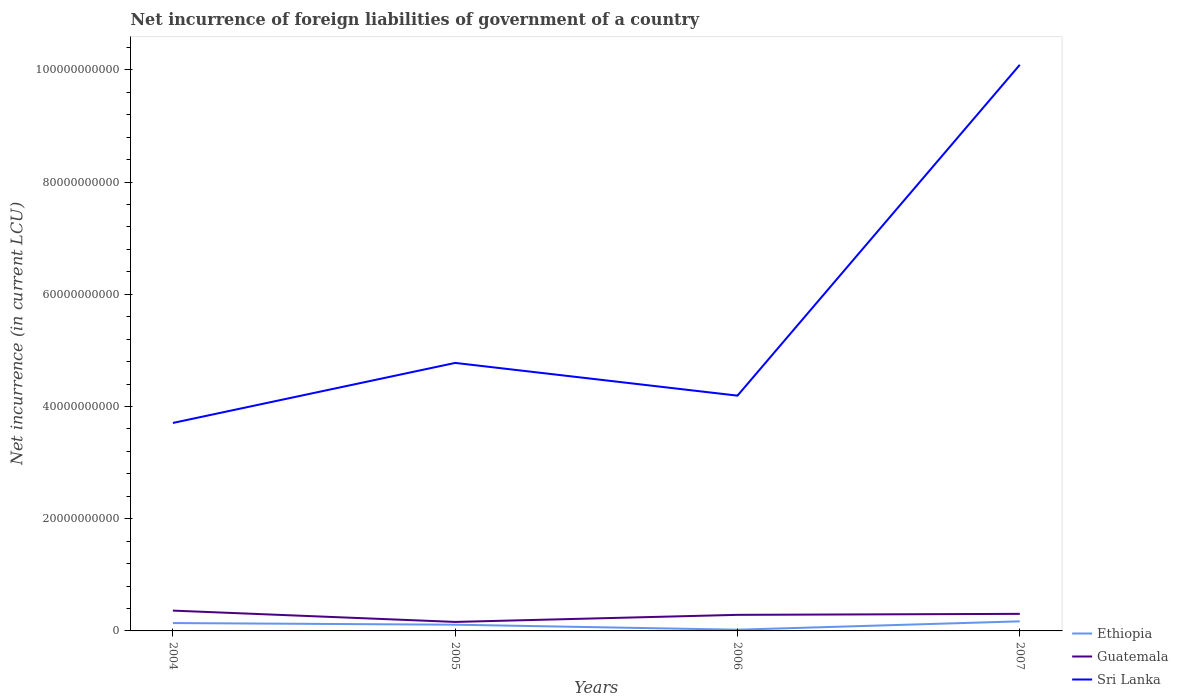Is the number of lines equal to the number of legend labels?
Offer a very short reply. Yes. Across all years, what is the maximum net incurrence of foreign liabilities in Sri Lanka?
Provide a succinct answer. 3.71e+1. What is the total net incurrence of foreign liabilities in Guatemala in the graph?
Your answer should be compact. -1.44e+09. What is the difference between the highest and the second highest net incurrence of foreign liabilities in Guatemala?
Provide a short and direct response. 2.02e+09. What is the difference between the highest and the lowest net incurrence of foreign liabilities in Sri Lanka?
Keep it short and to the point. 1. Are the values on the major ticks of Y-axis written in scientific E-notation?
Offer a very short reply. No. Does the graph contain any zero values?
Keep it short and to the point. No. How are the legend labels stacked?
Your answer should be compact. Vertical. What is the title of the graph?
Your response must be concise. Net incurrence of foreign liabilities of government of a country. What is the label or title of the X-axis?
Your response must be concise. Years. What is the label or title of the Y-axis?
Ensure brevity in your answer.  Net incurrence (in current LCU). What is the Net incurrence (in current LCU) in Ethiopia in 2004?
Make the answer very short. 1.40e+09. What is the Net incurrence (in current LCU) of Guatemala in 2004?
Make the answer very short. 3.62e+09. What is the Net incurrence (in current LCU) of Sri Lanka in 2004?
Make the answer very short. 3.71e+1. What is the Net incurrence (in current LCU) of Ethiopia in 2005?
Give a very brief answer. 1.11e+09. What is the Net incurrence (in current LCU) in Guatemala in 2005?
Ensure brevity in your answer.  1.60e+09. What is the Net incurrence (in current LCU) in Sri Lanka in 2005?
Keep it short and to the point. 4.78e+1. What is the Net incurrence (in current LCU) in Ethiopia in 2006?
Offer a terse response. 2.18e+08. What is the Net incurrence (in current LCU) of Guatemala in 2006?
Make the answer very short. 2.87e+09. What is the Net incurrence (in current LCU) of Sri Lanka in 2006?
Provide a succinct answer. 4.19e+1. What is the Net incurrence (in current LCU) of Ethiopia in 2007?
Offer a terse response. 1.71e+09. What is the Net incurrence (in current LCU) of Guatemala in 2007?
Your answer should be very brief. 3.04e+09. What is the Net incurrence (in current LCU) of Sri Lanka in 2007?
Keep it short and to the point. 1.01e+11. Across all years, what is the maximum Net incurrence (in current LCU) of Ethiopia?
Your answer should be very brief. 1.71e+09. Across all years, what is the maximum Net incurrence (in current LCU) of Guatemala?
Keep it short and to the point. 3.62e+09. Across all years, what is the maximum Net incurrence (in current LCU) in Sri Lanka?
Provide a succinct answer. 1.01e+11. Across all years, what is the minimum Net incurrence (in current LCU) in Ethiopia?
Your response must be concise. 2.18e+08. Across all years, what is the minimum Net incurrence (in current LCU) of Guatemala?
Offer a terse response. 1.60e+09. Across all years, what is the minimum Net incurrence (in current LCU) in Sri Lanka?
Give a very brief answer. 3.71e+1. What is the total Net incurrence (in current LCU) in Ethiopia in the graph?
Offer a terse response. 4.44e+09. What is the total Net incurrence (in current LCU) of Guatemala in the graph?
Provide a succinct answer. 1.11e+1. What is the total Net incurrence (in current LCU) in Sri Lanka in the graph?
Make the answer very short. 2.28e+11. What is the difference between the Net incurrence (in current LCU) of Ethiopia in 2004 and that in 2005?
Make the answer very short. 2.96e+08. What is the difference between the Net incurrence (in current LCU) of Guatemala in 2004 and that in 2005?
Provide a short and direct response. 2.02e+09. What is the difference between the Net incurrence (in current LCU) in Sri Lanka in 2004 and that in 2005?
Give a very brief answer. -1.07e+1. What is the difference between the Net incurrence (in current LCU) in Ethiopia in 2004 and that in 2006?
Make the answer very short. 1.18e+09. What is the difference between the Net incurrence (in current LCU) in Guatemala in 2004 and that in 2006?
Your response must be concise. 7.54e+08. What is the difference between the Net incurrence (in current LCU) in Sri Lanka in 2004 and that in 2006?
Provide a short and direct response. -4.87e+09. What is the difference between the Net incurrence (in current LCU) in Ethiopia in 2004 and that in 2007?
Your response must be concise. -3.04e+08. What is the difference between the Net incurrence (in current LCU) of Guatemala in 2004 and that in 2007?
Give a very brief answer. 5.80e+08. What is the difference between the Net incurrence (in current LCU) in Sri Lanka in 2004 and that in 2007?
Ensure brevity in your answer.  -6.38e+1. What is the difference between the Net incurrence (in current LCU) in Ethiopia in 2005 and that in 2006?
Your answer should be compact. 8.89e+08. What is the difference between the Net incurrence (in current LCU) in Guatemala in 2005 and that in 2006?
Keep it short and to the point. -1.26e+09. What is the difference between the Net incurrence (in current LCU) in Sri Lanka in 2005 and that in 2006?
Ensure brevity in your answer.  5.83e+09. What is the difference between the Net incurrence (in current LCU) in Ethiopia in 2005 and that in 2007?
Offer a very short reply. -6.00e+08. What is the difference between the Net incurrence (in current LCU) of Guatemala in 2005 and that in 2007?
Your answer should be very brief. -1.44e+09. What is the difference between the Net incurrence (in current LCU) in Sri Lanka in 2005 and that in 2007?
Your response must be concise. -5.31e+1. What is the difference between the Net incurrence (in current LCU) of Ethiopia in 2006 and that in 2007?
Your response must be concise. -1.49e+09. What is the difference between the Net incurrence (in current LCU) of Guatemala in 2006 and that in 2007?
Ensure brevity in your answer.  -1.74e+08. What is the difference between the Net incurrence (in current LCU) in Sri Lanka in 2006 and that in 2007?
Offer a very short reply. -5.90e+1. What is the difference between the Net incurrence (in current LCU) in Ethiopia in 2004 and the Net incurrence (in current LCU) in Guatemala in 2005?
Provide a short and direct response. -2.00e+08. What is the difference between the Net incurrence (in current LCU) in Ethiopia in 2004 and the Net incurrence (in current LCU) in Sri Lanka in 2005?
Make the answer very short. -4.64e+1. What is the difference between the Net incurrence (in current LCU) of Guatemala in 2004 and the Net incurrence (in current LCU) of Sri Lanka in 2005?
Offer a very short reply. -4.42e+1. What is the difference between the Net incurrence (in current LCU) of Ethiopia in 2004 and the Net incurrence (in current LCU) of Guatemala in 2006?
Keep it short and to the point. -1.46e+09. What is the difference between the Net incurrence (in current LCU) in Ethiopia in 2004 and the Net incurrence (in current LCU) in Sri Lanka in 2006?
Your answer should be very brief. -4.05e+1. What is the difference between the Net incurrence (in current LCU) in Guatemala in 2004 and the Net incurrence (in current LCU) in Sri Lanka in 2006?
Ensure brevity in your answer.  -3.83e+1. What is the difference between the Net incurrence (in current LCU) in Ethiopia in 2004 and the Net incurrence (in current LCU) in Guatemala in 2007?
Provide a short and direct response. -1.64e+09. What is the difference between the Net incurrence (in current LCU) of Ethiopia in 2004 and the Net incurrence (in current LCU) of Sri Lanka in 2007?
Ensure brevity in your answer.  -9.95e+1. What is the difference between the Net incurrence (in current LCU) of Guatemala in 2004 and the Net incurrence (in current LCU) of Sri Lanka in 2007?
Offer a very short reply. -9.73e+1. What is the difference between the Net incurrence (in current LCU) in Ethiopia in 2005 and the Net incurrence (in current LCU) in Guatemala in 2006?
Keep it short and to the point. -1.76e+09. What is the difference between the Net incurrence (in current LCU) of Ethiopia in 2005 and the Net incurrence (in current LCU) of Sri Lanka in 2006?
Your answer should be compact. -4.08e+1. What is the difference between the Net incurrence (in current LCU) of Guatemala in 2005 and the Net incurrence (in current LCU) of Sri Lanka in 2006?
Make the answer very short. -4.03e+1. What is the difference between the Net incurrence (in current LCU) of Ethiopia in 2005 and the Net incurrence (in current LCU) of Guatemala in 2007?
Keep it short and to the point. -1.93e+09. What is the difference between the Net incurrence (in current LCU) of Ethiopia in 2005 and the Net incurrence (in current LCU) of Sri Lanka in 2007?
Make the answer very short. -9.98e+1. What is the difference between the Net incurrence (in current LCU) in Guatemala in 2005 and the Net incurrence (in current LCU) in Sri Lanka in 2007?
Your answer should be very brief. -9.93e+1. What is the difference between the Net incurrence (in current LCU) of Ethiopia in 2006 and the Net incurrence (in current LCU) of Guatemala in 2007?
Ensure brevity in your answer.  -2.82e+09. What is the difference between the Net incurrence (in current LCU) of Ethiopia in 2006 and the Net incurrence (in current LCU) of Sri Lanka in 2007?
Offer a terse response. -1.01e+11. What is the difference between the Net incurrence (in current LCU) of Guatemala in 2006 and the Net incurrence (in current LCU) of Sri Lanka in 2007?
Provide a succinct answer. -9.80e+1. What is the average Net incurrence (in current LCU) of Ethiopia per year?
Ensure brevity in your answer.  1.11e+09. What is the average Net incurrence (in current LCU) in Guatemala per year?
Your answer should be compact. 2.78e+09. What is the average Net incurrence (in current LCU) of Sri Lanka per year?
Provide a short and direct response. 5.69e+1. In the year 2004, what is the difference between the Net incurrence (in current LCU) of Ethiopia and Net incurrence (in current LCU) of Guatemala?
Offer a very short reply. -2.22e+09. In the year 2004, what is the difference between the Net incurrence (in current LCU) of Ethiopia and Net incurrence (in current LCU) of Sri Lanka?
Your answer should be compact. -3.57e+1. In the year 2004, what is the difference between the Net incurrence (in current LCU) in Guatemala and Net incurrence (in current LCU) in Sri Lanka?
Your answer should be compact. -3.35e+1. In the year 2005, what is the difference between the Net incurrence (in current LCU) in Ethiopia and Net incurrence (in current LCU) in Guatemala?
Ensure brevity in your answer.  -4.96e+08. In the year 2005, what is the difference between the Net incurrence (in current LCU) of Ethiopia and Net incurrence (in current LCU) of Sri Lanka?
Ensure brevity in your answer.  -4.67e+1. In the year 2005, what is the difference between the Net incurrence (in current LCU) in Guatemala and Net incurrence (in current LCU) in Sri Lanka?
Give a very brief answer. -4.62e+1. In the year 2006, what is the difference between the Net incurrence (in current LCU) in Ethiopia and Net incurrence (in current LCU) in Guatemala?
Your answer should be compact. -2.65e+09. In the year 2006, what is the difference between the Net incurrence (in current LCU) of Ethiopia and Net incurrence (in current LCU) of Sri Lanka?
Your response must be concise. -4.17e+1. In the year 2006, what is the difference between the Net incurrence (in current LCU) of Guatemala and Net incurrence (in current LCU) of Sri Lanka?
Your answer should be very brief. -3.91e+1. In the year 2007, what is the difference between the Net incurrence (in current LCU) of Ethiopia and Net incurrence (in current LCU) of Guatemala?
Your answer should be very brief. -1.33e+09. In the year 2007, what is the difference between the Net incurrence (in current LCU) in Ethiopia and Net incurrence (in current LCU) in Sri Lanka?
Keep it short and to the point. -9.92e+1. In the year 2007, what is the difference between the Net incurrence (in current LCU) in Guatemala and Net incurrence (in current LCU) in Sri Lanka?
Offer a terse response. -9.79e+1. What is the ratio of the Net incurrence (in current LCU) in Ethiopia in 2004 to that in 2005?
Your response must be concise. 1.27. What is the ratio of the Net incurrence (in current LCU) of Guatemala in 2004 to that in 2005?
Keep it short and to the point. 2.26. What is the ratio of the Net incurrence (in current LCU) of Sri Lanka in 2004 to that in 2005?
Give a very brief answer. 0.78. What is the ratio of the Net incurrence (in current LCU) of Ethiopia in 2004 to that in 2006?
Offer a terse response. 6.42. What is the ratio of the Net incurrence (in current LCU) of Guatemala in 2004 to that in 2006?
Provide a succinct answer. 1.26. What is the ratio of the Net incurrence (in current LCU) in Sri Lanka in 2004 to that in 2006?
Make the answer very short. 0.88. What is the ratio of the Net incurrence (in current LCU) in Ethiopia in 2004 to that in 2007?
Offer a very short reply. 0.82. What is the ratio of the Net incurrence (in current LCU) of Guatemala in 2004 to that in 2007?
Your response must be concise. 1.19. What is the ratio of the Net incurrence (in current LCU) of Sri Lanka in 2004 to that in 2007?
Give a very brief answer. 0.37. What is the ratio of the Net incurrence (in current LCU) in Ethiopia in 2005 to that in 2006?
Your answer should be compact. 5.07. What is the ratio of the Net incurrence (in current LCU) in Guatemala in 2005 to that in 2006?
Make the answer very short. 0.56. What is the ratio of the Net incurrence (in current LCU) in Sri Lanka in 2005 to that in 2006?
Keep it short and to the point. 1.14. What is the ratio of the Net incurrence (in current LCU) in Ethiopia in 2005 to that in 2007?
Keep it short and to the point. 0.65. What is the ratio of the Net incurrence (in current LCU) in Guatemala in 2005 to that in 2007?
Provide a short and direct response. 0.53. What is the ratio of the Net incurrence (in current LCU) of Sri Lanka in 2005 to that in 2007?
Give a very brief answer. 0.47. What is the ratio of the Net incurrence (in current LCU) of Ethiopia in 2006 to that in 2007?
Make the answer very short. 0.13. What is the ratio of the Net incurrence (in current LCU) of Guatemala in 2006 to that in 2007?
Keep it short and to the point. 0.94. What is the ratio of the Net incurrence (in current LCU) in Sri Lanka in 2006 to that in 2007?
Your answer should be compact. 0.42. What is the difference between the highest and the second highest Net incurrence (in current LCU) of Ethiopia?
Keep it short and to the point. 3.04e+08. What is the difference between the highest and the second highest Net incurrence (in current LCU) in Guatemala?
Your answer should be compact. 5.80e+08. What is the difference between the highest and the second highest Net incurrence (in current LCU) in Sri Lanka?
Ensure brevity in your answer.  5.31e+1. What is the difference between the highest and the lowest Net incurrence (in current LCU) in Ethiopia?
Offer a terse response. 1.49e+09. What is the difference between the highest and the lowest Net incurrence (in current LCU) of Guatemala?
Provide a succinct answer. 2.02e+09. What is the difference between the highest and the lowest Net incurrence (in current LCU) in Sri Lanka?
Make the answer very short. 6.38e+1. 